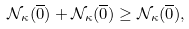<formula> <loc_0><loc_0><loc_500><loc_500>\mathcal { N } _ { \kappa } ( \overline { 0 } ) + \mathcal { N } _ { \kappa } ( \overline { 0 } ) \geq \mathcal { N } _ { \kappa } ( \overline { 0 } ) ,</formula> 